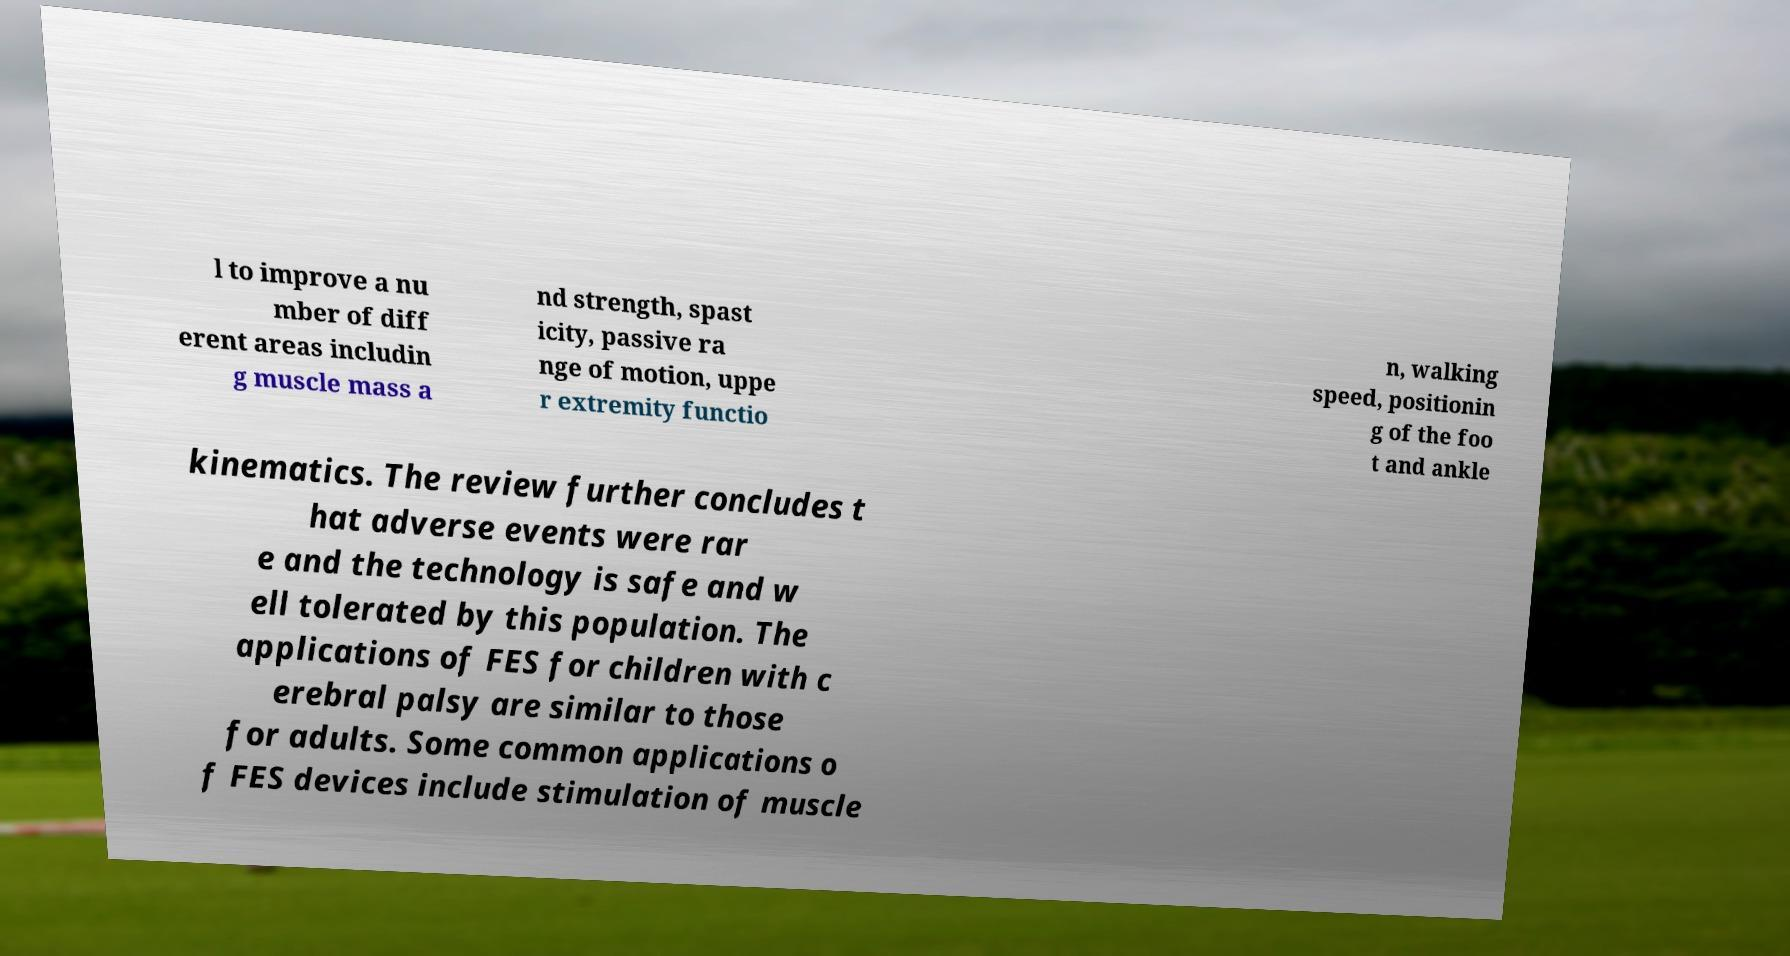Could you assist in decoding the text presented in this image and type it out clearly? l to improve a nu mber of diff erent areas includin g muscle mass a nd strength, spast icity, passive ra nge of motion, uppe r extremity functio n, walking speed, positionin g of the foo t and ankle kinematics. The review further concludes t hat adverse events were rar e and the technology is safe and w ell tolerated by this population. The applications of FES for children with c erebral palsy are similar to those for adults. Some common applications o f FES devices include stimulation of muscle 